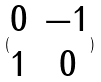Convert formula to latex. <formula><loc_0><loc_0><loc_500><loc_500>( \begin{matrix} 0 & - 1 \\ 1 & 0 \end{matrix} )</formula> 